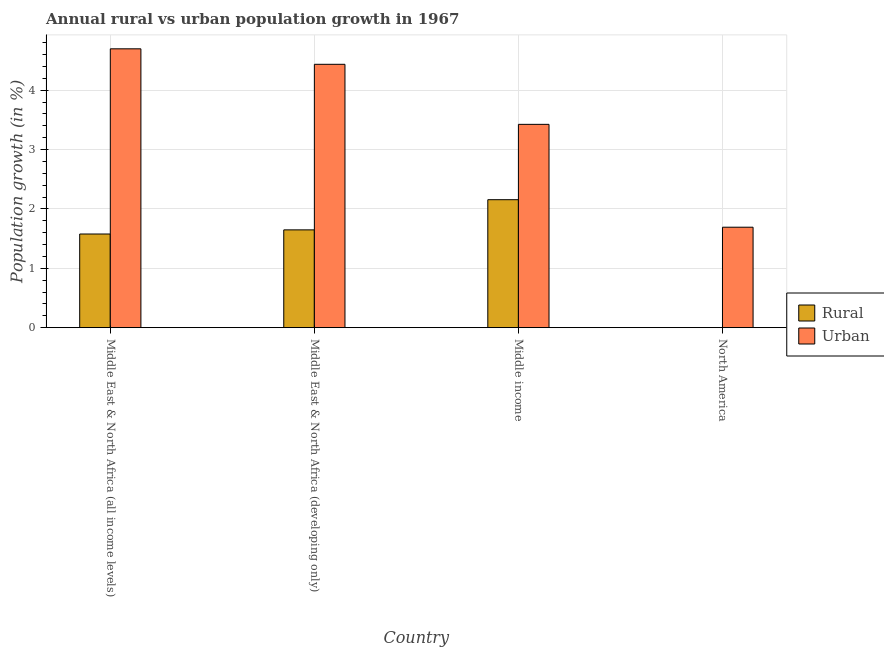How many different coloured bars are there?
Provide a short and direct response. 2. Are the number of bars on each tick of the X-axis equal?
Offer a terse response. No. What is the label of the 4th group of bars from the left?
Ensure brevity in your answer.  North America. In how many cases, is the number of bars for a given country not equal to the number of legend labels?
Your response must be concise. 1. What is the urban population growth in Middle income?
Offer a terse response. 3.42. Across all countries, what is the maximum urban population growth?
Your answer should be very brief. 4.7. Across all countries, what is the minimum urban population growth?
Give a very brief answer. 1.69. In which country was the urban population growth maximum?
Your answer should be compact. Middle East & North Africa (all income levels). What is the total rural population growth in the graph?
Your answer should be very brief. 5.38. What is the difference between the urban population growth in Middle income and that in North America?
Offer a very short reply. 1.73. What is the difference between the urban population growth in Middle East & North Africa (developing only) and the rural population growth in Middle East & North Africa (all income levels)?
Make the answer very short. 2.86. What is the average rural population growth per country?
Offer a terse response. 1.35. What is the difference between the rural population growth and urban population growth in Middle East & North Africa (developing only)?
Your answer should be compact. -2.79. In how many countries, is the rural population growth greater than 4.6 %?
Your answer should be compact. 0. What is the ratio of the rural population growth in Middle East & North Africa (all income levels) to that in Middle income?
Ensure brevity in your answer.  0.73. Is the urban population growth in Middle East & North Africa (all income levels) less than that in North America?
Make the answer very short. No. Is the difference between the rural population growth in Middle East & North Africa (developing only) and Middle income greater than the difference between the urban population growth in Middle East & North Africa (developing only) and Middle income?
Offer a terse response. No. What is the difference between the highest and the second highest rural population growth?
Give a very brief answer. 0.51. What is the difference between the highest and the lowest urban population growth?
Your response must be concise. 3. Is the sum of the urban population growth in Middle East & North Africa (all income levels) and Middle income greater than the maximum rural population growth across all countries?
Provide a short and direct response. Yes. How many bars are there?
Provide a short and direct response. 7. Are all the bars in the graph horizontal?
Provide a short and direct response. No. How many countries are there in the graph?
Provide a short and direct response. 4. What is the difference between two consecutive major ticks on the Y-axis?
Make the answer very short. 1. Are the values on the major ticks of Y-axis written in scientific E-notation?
Offer a very short reply. No. Does the graph contain grids?
Your answer should be very brief. Yes. What is the title of the graph?
Ensure brevity in your answer.  Annual rural vs urban population growth in 1967. What is the label or title of the X-axis?
Your answer should be very brief. Country. What is the label or title of the Y-axis?
Provide a short and direct response. Population growth (in %). What is the Population growth (in %) of Rural in Middle East & North Africa (all income levels)?
Keep it short and to the point. 1.58. What is the Population growth (in %) in Urban  in Middle East & North Africa (all income levels)?
Keep it short and to the point. 4.7. What is the Population growth (in %) in Rural in Middle East & North Africa (developing only)?
Keep it short and to the point. 1.65. What is the Population growth (in %) in Urban  in Middle East & North Africa (developing only)?
Provide a short and direct response. 4.44. What is the Population growth (in %) of Rural in Middle income?
Ensure brevity in your answer.  2.16. What is the Population growth (in %) of Urban  in Middle income?
Your response must be concise. 3.42. What is the Population growth (in %) in Rural in North America?
Your answer should be very brief. 0. What is the Population growth (in %) of Urban  in North America?
Ensure brevity in your answer.  1.69. Across all countries, what is the maximum Population growth (in %) of Rural?
Your answer should be compact. 2.16. Across all countries, what is the maximum Population growth (in %) of Urban ?
Ensure brevity in your answer.  4.7. Across all countries, what is the minimum Population growth (in %) in Rural?
Offer a terse response. 0. Across all countries, what is the minimum Population growth (in %) of Urban ?
Your answer should be compact. 1.69. What is the total Population growth (in %) of Rural in the graph?
Ensure brevity in your answer.  5.38. What is the total Population growth (in %) in Urban  in the graph?
Provide a short and direct response. 14.25. What is the difference between the Population growth (in %) of Rural in Middle East & North Africa (all income levels) and that in Middle East & North Africa (developing only)?
Keep it short and to the point. -0.07. What is the difference between the Population growth (in %) of Urban  in Middle East & North Africa (all income levels) and that in Middle East & North Africa (developing only)?
Keep it short and to the point. 0.26. What is the difference between the Population growth (in %) of Rural in Middle East & North Africa (all income levels) and that in Middle income?
Give a very brief answer. -0.58. What is the difference between the Population growth (in %) of Urban  in Middle East & North Africa (all income levels) and that in Middle income?
Your answer should be very brief. 1.27. What is the difference between the Population growth (in %) in Urban  in Middle East & North Africa (all income levels) and that in North America?
Offer a very short reply. 3. What is the difference between the Population growth (in %) in Rural in Middle East & North Africa (developing only) and that in Middle income?
Your answer should be compact. -0.51. What is the difference between the Population growth (in %) in Urban  in Middle East & North Africa (developing only) and that in Middle income?
Offer a very short reply. 1.01. What is the difference between the Population growth (in %) in Urban  in Middle East & North Africa (developing only) and that in North America?
Your answer should be compact. 2.74. What is the difference between the Population growth (in %) in Urban  in Middle income and that in North America?
Give a very brief answer. 1.73. What is the difference between the Population growth (in %) of Rural in Middle East & North Africa (all income levels) and the Population growth (in %) of Urban  in Middle East & North Africa (developing only)?
Ensure brevity in your answer.  -2.86. What is the difference between the Population growth (in %) in Rural in Middle East & North Africa (all income levels) and the Population growth (in %) in Urban  in Middle income?
Offer a terse response. -1.85. What is the difference between the Population growth (in %) of Rural in Middle East & North Africa (all income levels) and the Population growth (in %) of Urban  in North America?
Your answer should be very brief. -0.11. What is the difference between the Population growth (in %) in Rural in Middle East & North Africa (developing only) and the Population growth (in %) in Urban  in Middle income?
Provide a short and direct response. -1.78. What is the difference between the Population growth (in %) in Rural in Middle East & North Africa (developing only) and the Population growth (in %) in Urban  in North America?
Your response must be concise. -0.04. What is the difference between the Population growth (in %) of Rural in Middle income and the Population growth (in %) of Urban  in North America?
Your response must be concise. 0.46. What is the average Population growth (in %) in Rural per country?
Ensure brevity in your answer.  1.35. What is the average Population growth (in %) in Urban  per country?
Give a very brief answer. 3.56. What is the difference between the Population growth (in %) of Rural and Population growth (in %) of Urban  in Middle East & North Africa (all income levels)?
Provide a short and direct response. -3.12. What is the difference between the Population growth (in %) in Rural and Population growth (in %) in Urban  in Middle East & North Africa (developing only)?
Ensure brevity in your answer.  -2.79. What is the difference between the Population growth (in %) of Rural and Population growth (in %) of Urban  in Middle income?
Keep it short and to the point. -1.27. What is the ratio of the Population growth (in %) in Rural in Middle East & North Africa (all income levels) to that in Middle East & North Africa (developing only)?
Give a very brief answer. 0.96. What is the ratio of the Population growth (in %) of Urban  in Middle East & North Africa (all income levels) to that in Middle East & North Africa (developing only)?
Make the answer very short. 1.06. What is the ratio of the Population growth (in %) in Rural in Middle East & North Africa (all income levels) to that in Middle income?
Make the answer very short. 0.73. What is the ratio of the Population growth (in %) in Urban  in Middle East & North Africa (all income levels) to that in Middle income?
Your answer should be compact. 1.37. What is the ratio of the Population growth (in %) of Urban  in Middle East & North Africa (all income levels) to that in North America?
Give a very brief answer. 2.78. What is the ratio of the Population growth (in %) of Rural in Middle East & North Africa (developing only) to that in Middle income?
Provide a short and direct response. 0.76. What is the ratio of the Population growth (in %) in Urban  in Middle East & North Africa (developing only) to that in Middle income?
Make the answer very short. 1.3. What is the ratio of the Population growth (in %) of Urban  in Middle East & North Africa (developing only) to that in North America?
Provide a succinct answer. 2.62. What is the ratio of the Population growth (in %) in Urban  in Middle income to that in North America?
Your answer should be compact. 2.02. What is the difference between the highest and the second highest Population growth (in %) of Rural?
Offer a terse response. 0.51. What is the difference between the highest and the second highest Population growth (in %) of Urban ?
Offer a terse response. 0.26. What is the difference between the highest and the lowest Population growth (in %) of Rural?
Your answer should be very brief. 2.16. What is the difference between the highest and the lowest Population growth (in %) of Urban ?
Keep it short and to the point. 3. 